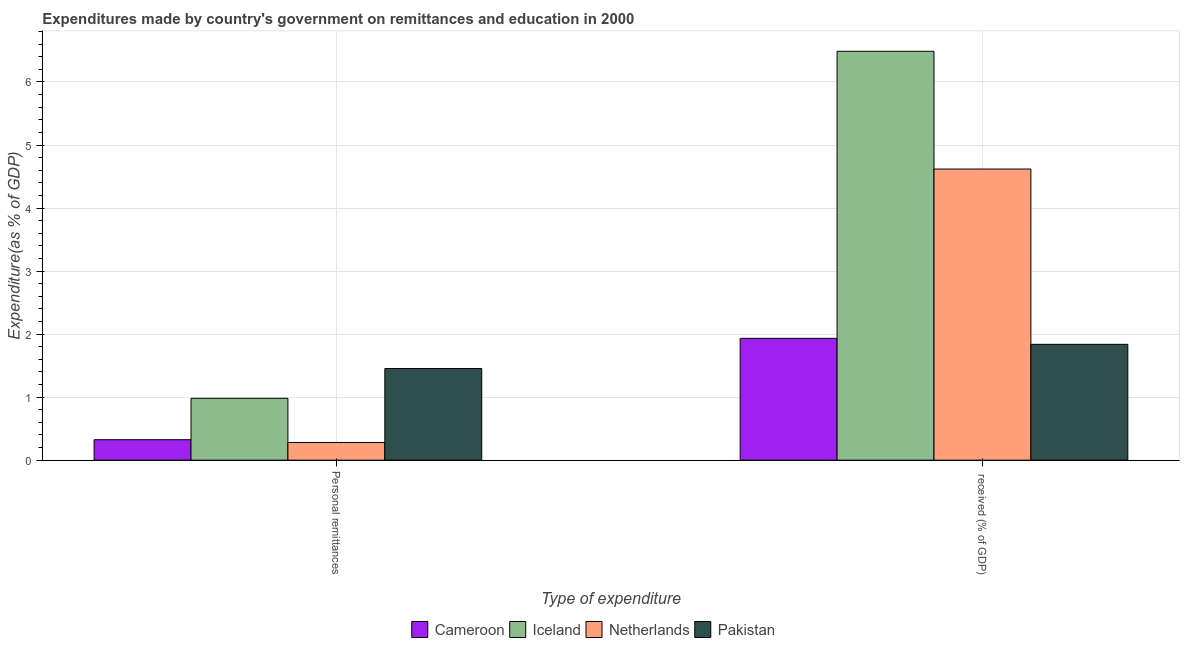How many bars are there on the 2nd tick from the right?
Your answer should be compact. 4. What is the label of the 1st group of bars from the left?
Ensure brevity in your answer.  Personal remittances. What is the expenditure in personal remittances in Netherlands?
Offer a very short reply. 0.28. Across all countries, what is the maximum expenditure in personal remittances?
Offer a terse response. 1.45. Across all countries, what is the minimum expenditure in education?
Give a very brief answer. 1.84. In which country was the expenditure in personal remittances maximum?
Your response must be concise. Pakistan. In which country was the expenditure in education minimum?
Your answer should be compact. Pakistan. What is the total expenditure in personal remittances in the graph?
Keep it short and to the point. 3.04. What is the difference between the expenditure in personal remittances in Cameroon and that in Netherlands?
Offer a terse response. 0.04. What is the difference between the expenditure in education in Netherlands and the expenditure in personal remittances in Iceland?
Ensure brevity in your answer.  3.64. What is the average expenditure in personal remittances per country?
Ensure brevity in your answer.  0.76. What is the difference between the expenditure in personal remittances and expenditure in education in Cameroon?
Make the answer very short. -1.61. In how many countries, is the expenditure in education greater than 3.6 %?
Offer a terse response. 2. What is the ratio of the expenditure in personal remittances in Cameroon to that in Pakistan?
Offer a terse response. 0.22. In how many countries, is the expenditure in personal remittances greater than the average expenditure in personal remittances taken over all countries?
Your answer should be compact. 2. What does the 1st bar from the left in Personal remittances represents?
Provide a short and direct response. Cameroon. What is the difference between two consecutive major ticks on the Y-axis?
Ensure brevity in your answer.  1. Are the values on the major ticks of Y-axis written in scientific E-notation?
Your response must be concise. No. Does the graph contain grids?
Make the answer very short. Yes. Where does the legend appear in the graph?
Keep it short and to the point. Bottom center. How many legend labels are there?
Offer a very short reply. 4. What is the title of the graph?
Provide a short and direct response. Expenditures made by country's government on remittances and education in 2000. What is the label or title of the X-axis?
Offer a terse response. Type of expenditure. What is the label or title of the Y-axis?
Provide a succinct answer. Expenditure(as % of GDP). What is the Expenditure(as % of GDP) in Cameroon in Personal remittances?
Give a very brief answer. 0.32. What is the Expenditure(as % of GDP) of Iceland in Personal remittances?
Ensure brevity in your answer.  0.98. What is the Expenditure(as % of GDP) in Netherlands in Personal remittances?
Make the answer very short. 0.28. What is the Expenditure(as % of GDP) of Pakistan in Personal remittances?
Give a very brief answer. 1.45. What is the Expenditure(as % of GDP) in Cameroon in  received (% of GDP)?
Offer a terse response. 1.93. What is the Expenditure(as % of GDP) in Iceland in  received (% of GDP)?
Your answer should be very brief. 6.49. What is the Expenditure(as % of GDP) in Netherlands in  received (% of GDP)?
Your response must be concise. 4.62. What is the Expenditure(as % of GDP) of Pakistan in  received (% of GDP)?
Your answer should be very brief. 1.84. Across all Type of expenditure, what is the maximum Expenditure(as % of GDP) in Cameroon?
Give a very brief answer. 1.93. Across all Type of expenditure, what is the maximum Expenditure(as % of GDP) in Iceland?
Offer a very short reply. 6.49. Across all Type of expenditure, what is the maximum Expenditure(as % of GDP) of Netherlands?
Your answer should be compact. 4.62. Across all Type of expenditure, what is the maximum Expenditure(as % of GDP) of Pakistan?
Your answer should be compact. 1.84. Across all Type of expenditure, what is the minimum Expenditure(as % of GDP) of Cameroon?
Make the answer very short. 0.32. Across all Type of expenditure, what is the minimum Expenditure(as % of GDP) of Iceland?
Offer a very short reply. 0.98. Across all Type of expenditure, what is the minimum Expenditure(as % of GDP) of Netherlands?
Give a very brief answer. 0.28. Across all Type of expenditure, what is the minimum Expenditure(as % of GDP) of Pakistan?
Offer a very short reply. 1.45. What is the total Expenditure(as % of GDP) of Cameroon in the graph?
Give a very brief answer. 2.26. What is the total Expenditure(as % of GDP) in Iceland in the graph?
Ensure brevity in your answer.  7.47. What is the total Expenditure(as % of GDP) in Netherlands in the graph?
Your answer should be compact. 4.9. What is the total Expenditure(as % of GDP) in Pakistan in the graph?
Ensure brevity in your answer.  3.29. What is the difference between the Expenditure(as % of GDP) of Cameroon in Personal remittances and that in  received (% of GDP)?
Your answer should be compact. -1.61. What is the difference between the Expenditure(as % of GDP) of Iceland in Personal remittances and that in  received (% of GDP)?
Keep it short and to the point. -5.51. What is the difference between the Expenditure(as % of GDP) in Netherlands in Personal remittances and that in  received (% of GDP)?
Offer a very short reply. -4.34. What is the difference between the Expenditure(as % of GDP) in Pakistan in Personal remittances and that in  received (% of GDP)?
Your answer should be very brief. -0.38. What is the difference between the Expenditure(as % of GDP) in Cameroon in Personal remittances and the Expenditure(as % of GDP) in Iceland in  received (% of GDP)?
Offer a terse response. -6.16. What is the difference between the Expenditure(as % of GDP) in Cameroon in Personal remittances and the Expenditure(as % of GDP) in Netherlands in  received (% of GDP)?
Ensure brevity in your answer.  -4.29. What is the difference between the Expenditure(as % of GDP) in Cameroon in Personal remittances and the Expenditure(as % of GDP) in Pakistan in  received (% of GDP)?
Keep it short and to the point. -1.51. What is the difference between the Expenditure(as % of GDP) in Iceland in Personal remittances and the Expenditure(as % of GDP) in Netherlands in  received (% of GDP)?
Offer a terse response. -3.64. What is the difference between the Expenditure(as % of GDP) in Iceland in Personal remittances and the Expenditure(as % of GDP) in Pakistan in  received (% of GDP)?
Offer a very short reply. -0.86. What is the difference between the Expenditure(as % of GDP) in Netherlands in Personal remittances and the Expenditure(as % of GDP) in Pakistan in  received (% of GDP)?
Make the answer very short. -1.56. What is the average Expenditure(as % of GDP) of Cameroon per Type of expenditure?
Offer a very short reply. 1.13. What is the average Expenditure(as % of GDP) of Iceland per Type of expenditure?
Your answer should be very brief. 3.73. What is the average Expenditure(as % of GDP) of Netherlands per Type of expenditure?
Keep it short and to the point. 2.45. What is the average Expenditure(as % of GDP) of Pakistan per Type of expenditure?
Offer a terse response. 1.65. What is the difference between the Expenditure(as % of GDP) of Cameroon and Expenditure(as % of GDP) of Iceland in Personal remittances?
Offer a terse response. -0.66. What is the difference between the Expenditure(as % of GDP) in Cameroon and Expenditure(as % of GDP) in Netherlands in Personal remittances?
Ensure brevity in your answer.  0.04. What is the difference between the Expenditure(as % of GDP) of Cameroon and Expenditure(as % of GDP) of Pakistan in Personal remittances?
Ensure brevity in your answer.  -1.13. What is the difference between the Expenditure(as % of GDP) of Iceland and Expenditure(as % of GDP) of Netherlands in Personal remittances?
Make the answer very short. 0.7. What is the difference between the Expenditure(as % of GDP) in Iceland and Expenditure(as % of GDP) in Pakistan in Personal remittances?
Provide a short and direct response. -0.47. What is the difference between the Expenditure(as % of GDP) of Netherlands and Expenditure(as % of GDP) of Pakistan in Personal remittances?
Your response must be concise. -1.17. What is the difference between the Expenditure(as % of GDP) in Cameroon and Expenditure(as % of GDP) in Iceland in  received (% of GDP)?
Provide a short and direct response. -4.55. What is the difference between the Expenditure(as % of GDP) in Cameroon and Expenditure(as % of GDP) in Netherlands in  received (% of GDP)?
Give a very brief answer. -2.69. What is the difference between the Expenditure(as % of GDP) in Cameroon and Expenditure(as % of GDP) in Pakistan in  received (% of GDP)?
Offer a terse response. 0.09. What is the difference between the Expenditure(as % of GDP) in Iceland and Expenditure(as % of GDP) in Netherlands in  received (% of GDP)?
Keep it short and to the point. 1.87. What is the difference between the Expenditure(as % of GDP) of Iceland and Expenditure(as % of GDP) of Pakistan in  received (% of GDP)?
Provide a short and direct response. 4.65. What is the difference between the Expenditure(as % of GDP) in Netherlands and Expenditure(as % of GDP) in Pakistan in  received (% of GDP)?
Keep it short and to the point. 2.78. What is the ratio of the Expenditure(as % of GDP) in Cameroon in Personal remittances to that in  received (% of GDP)?
Provide a succinct answer. 0.17. What is the ratio of the Expenditure(as % of GDP) in Iceland in Personal remittances to that in  received (% of GDP)?
Your answer should be very brief. 0.15. What is the ratio of the Expenditure(as % of GDP) in Netherlands in Personal remittances to that in  received (% of GDP)?
Keep it short and to the point. 0.06. What is the ratio of the Expenditure(as % of GDP) of Pakistan in Personal remittances to that in  received (% of GDP)?
Offer a terse response. 0.79. What is the difference between the highest and the second highest Expenditure(as % of GDP) of Cameroon?
Make the answer very short. 1.61. What is the difference between the highest and the second highest Expenditure(as % of GDP) of Iceland?
Keep it short and to the point. 5.51. What is the difference between the highest and the second highest Expenditure(as % of GDP) of Netherlands?
Your answer should be very brief. 4.34. What is the difference between the highest and the second highest Expenditure(as % of GDP) in Pakistan?
Your answer should be compact. 0.38. What is the difference between the highest and the lowest Expenditure(as % of GDP) of Cameroon?
Your answer should be compact. 1.61. What is the difference between the highest and the lowest Expenditure(as % of GDP) of Iceland?
Provide a succinct answer. 5.51. What is the difference between the highest and the lowest Expenditure(as % of GDP) in Netherlands?
Give a very brief answer. 4.34. What is the difference between the highest and the lowest Expenditure(as % of GDP) of Pakistan?
Offer a very short reply. 0.38. 